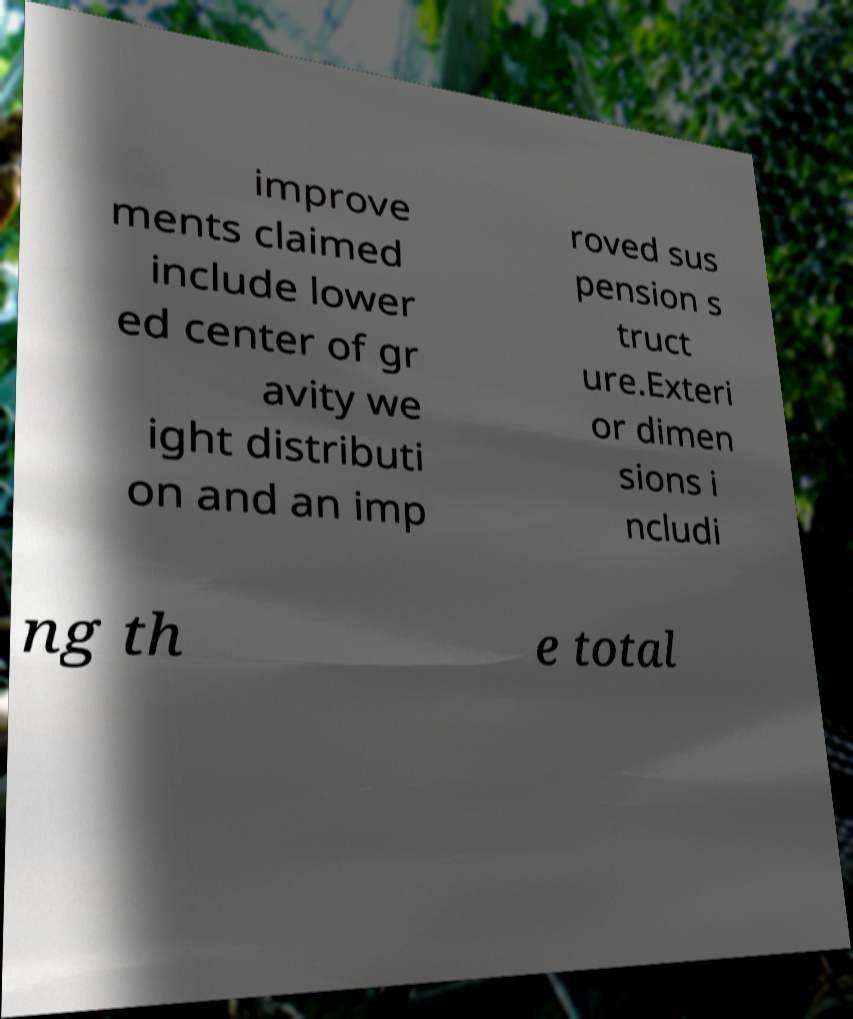Can you accurately transcribe the text from the provided image for me? improve ments claimed include lower ed center of gr avity we ight distributi on and an imp roved sus pension s truct ure.Exteri or dimen sions i ncludi ng th e total 